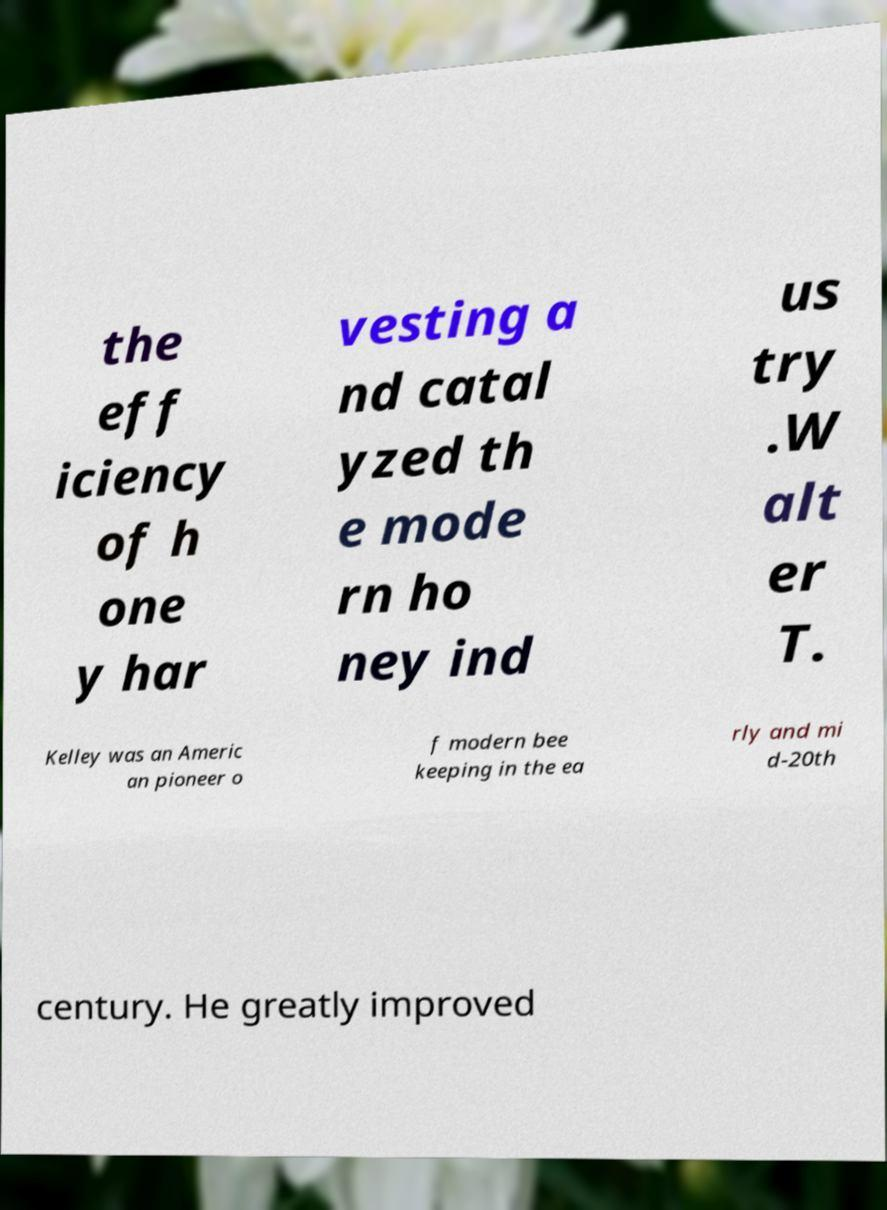Can you read and provide the text displayed in the image?This photo seems to have some interesting text. Can you extract and type it out for me? the eff iciency of h one y har vesting a nd catal yzed th e mode rn ho ney ind us try .W alt er T. Kelley was an Americ an pioneer o f modern bee keeping in the ea rly and mi d-20th century. He greatly improved 